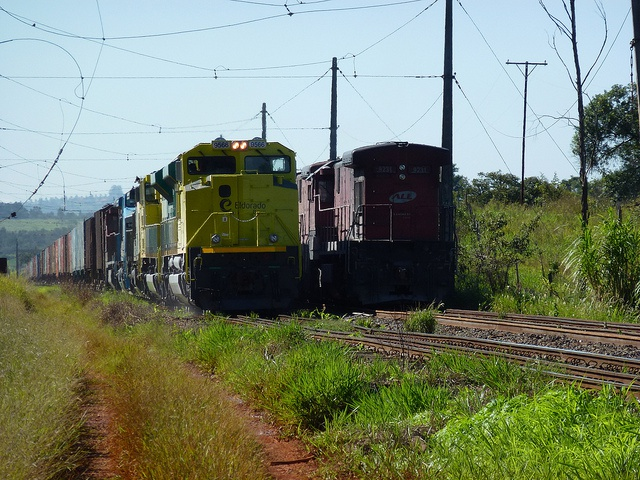Describe the objects in this image and their specific colors. I can see train in lightblue, black, gray, and darkgreen tones and train in lightblue, black, darkgray, gray, and lightgray tones in this image. 